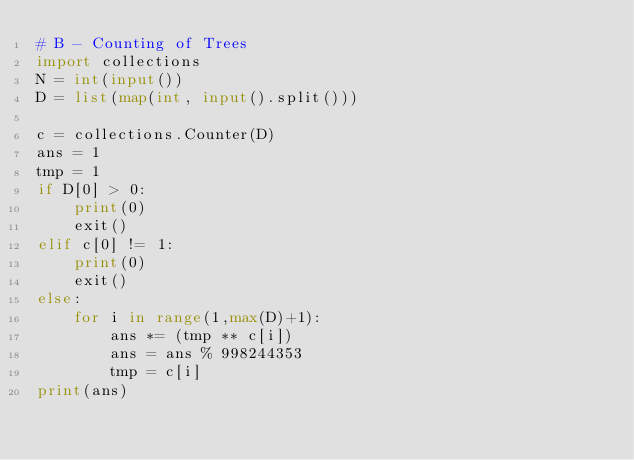Convert code to text. <code><loc_0><loc_0><loc_500><loc_500><_Python_># B - Counting of Trees
import collections
N = int(input())
D = list(map(int, input().split()))

c = collections.Counter(D)
ans = 1
tmp = 1
if D[0] > 0:
    print(0)
    exit()
elif c[0] != 1:
    print(0)
    exit()
else:
    for i in range(1,max(D)+1):
        ans *= (tmp ** c[i])
        ans = ans % 998244353
        tmp = c[i]
print(ans)</code> 